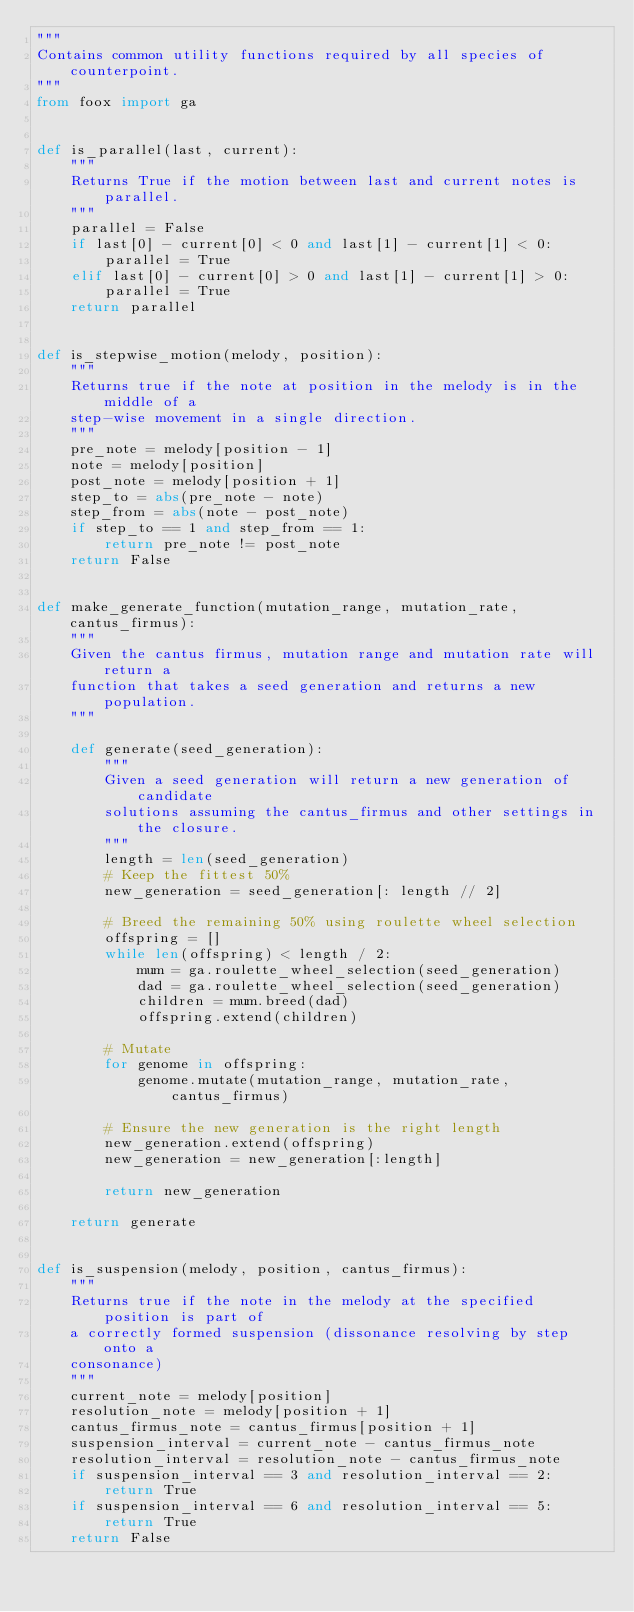Convert code to text. <code><loc_0><loc_0><loc_500><loc_500><_Python_>"""
Contains common utility functions required by all species of counterpoint.
"""
from foox import ga


def is_parallel(last, current):
    """
    Returns True if the motion between last and current notes is parallel.
    """
    parallel = False
    if last[0] - current[0] < 0 and last[1] - current[1] < 0:
        parallel = True
    elif last[0] - current[0] > 0 and last[1] - current[1] > 0:
        parallel = True
    return parallel


def is_stepwise_motion(melody, position):
    """
    Returns true if the note at position in the melody is in the middle of a
    step-wise movement in a single direction.
    """
    pre_note = melody[position - 1]
    note = melody[position]
    post_note = melody[position + 1]
    step_to = abs(pre_note - note)
    step_from = abs(note - post_note)
    if step_to == 1 and step_from == 1:
        return pre_note != post_note
    return False


def make_generate_function(mutation_range, mutation_rate, cantus_firmus):
    """
    Given the cantus firmus, mutation range and mutation rate will return a
    function that takes a seed generation and returns a new population.
    """

    def generate(seed_generation):
        """
        Given a seed generation will return a new generation of candidate
        solutions assuming the cantus_firmus and other settings in the closure.
        """
        length = len(seed_generation)
        # Keep the fittest 50%
        new_generation = seed_generation[: length // 2]

        # Breed the remaining 50% using roulette wheel selection
        offspring = []
        while len(offspring) < length / 2:
            mum = ga.roulette_wheel_selection(seed_generation)
            dad = ga.roulette_wheel_selection(seed_generation)
            children = mum.breed(dad)
            offspring.extend(children)

        # Mutate
        for genome in offspring:
            genome.mutate(mutation_range, mutation_rate, cantus_firmus)

        # Ensure the new generation is the right length
        new_generation.extend(offspring)
        new_generation = new_generation[:length]

        return new_generation

    return generate


def is_suspension(melody, position, cantus_firmus):
    """
    Returns true if the note in the melody at the specified position is part of
    a correctly formed suspension (dissonance resolving by step onto a
    consonance)
    """
    current_note = melody[position]
    resolution_note = melody[position + 1]
    cantus_firmus_note = cantus_firmus[position + 1]
    suspension_interval = current_note - cantus_firmus_note
    resolution_interval = resolution_note - cantus_firmus_note
    if suspension_interval == 3 and resolution_interval == 2:
        return True
    if suspension_interval == 6 and resolution_interval == 5:
        return True
    return False
</code> 